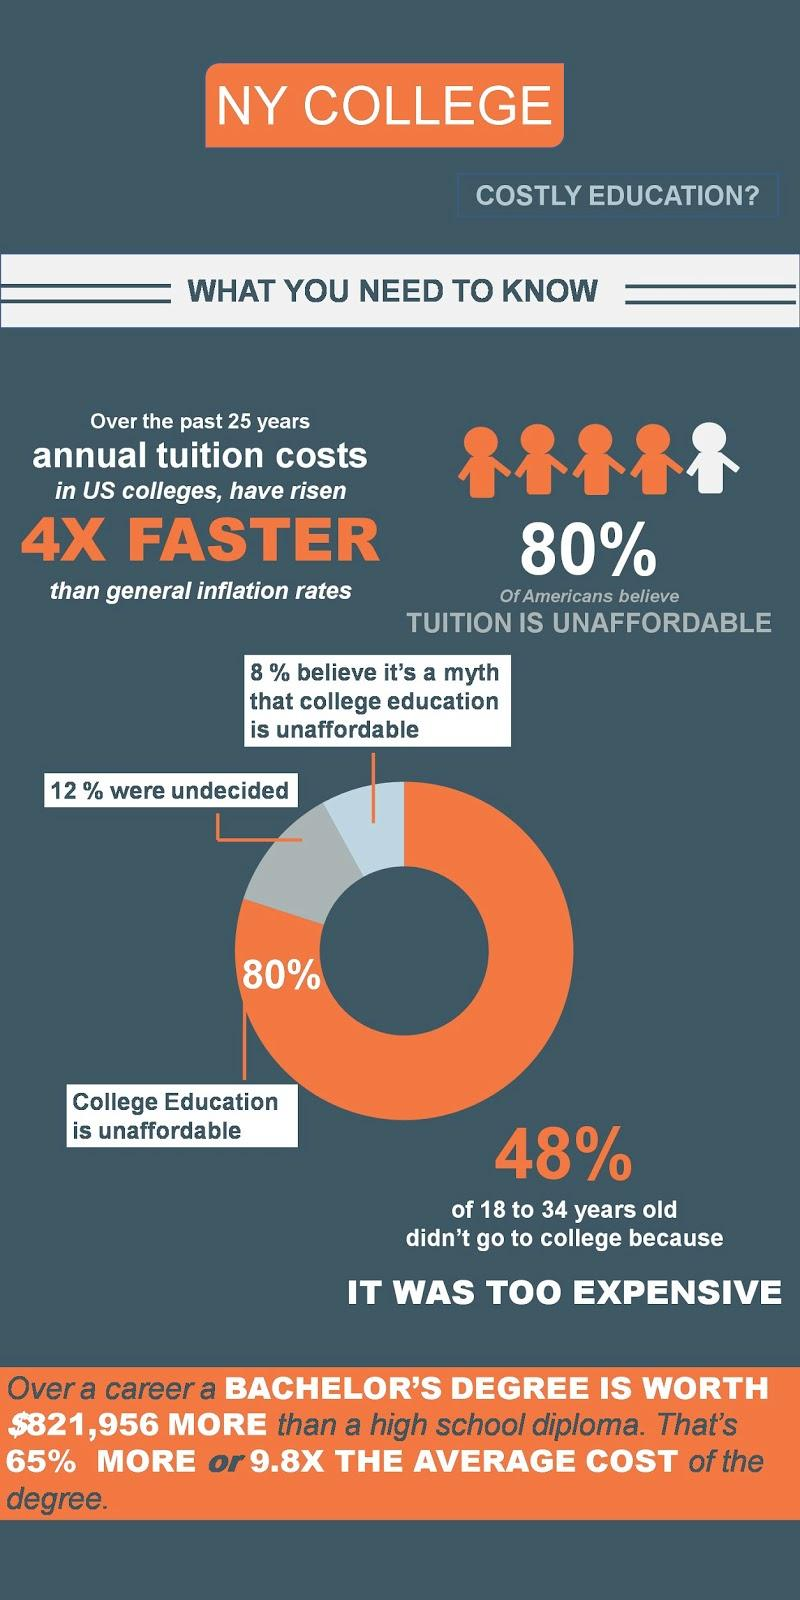Highlight a few significant elements in this photo. According to a survey, an overwhelming 80% of Americans believe that college education is unaffordable. 